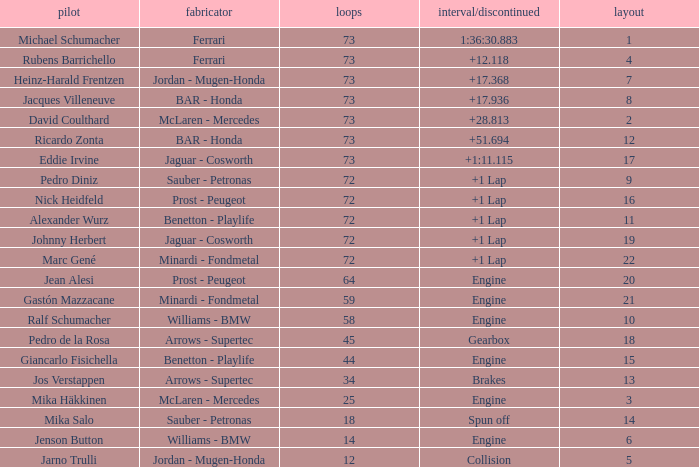How many laps did Giancarlo Fisichella do with a grid larger than 15? 0.0. 